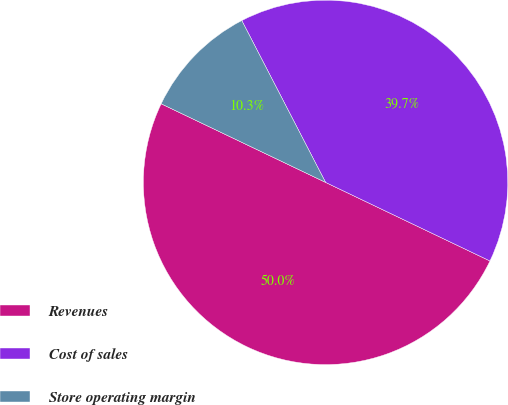<chart> <loc_0><loc_0><loc_500><loc_500><pie_chart><fcel>Revenues<fcel>Cost of sales<fcel>Store operating margin<nl><fcel>50.0%<fcel>39.7%<fcel>10.3%<nl></chart> 